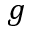<formula> <loc_0><loc_0><loc_500><loc_500>g</formula> 